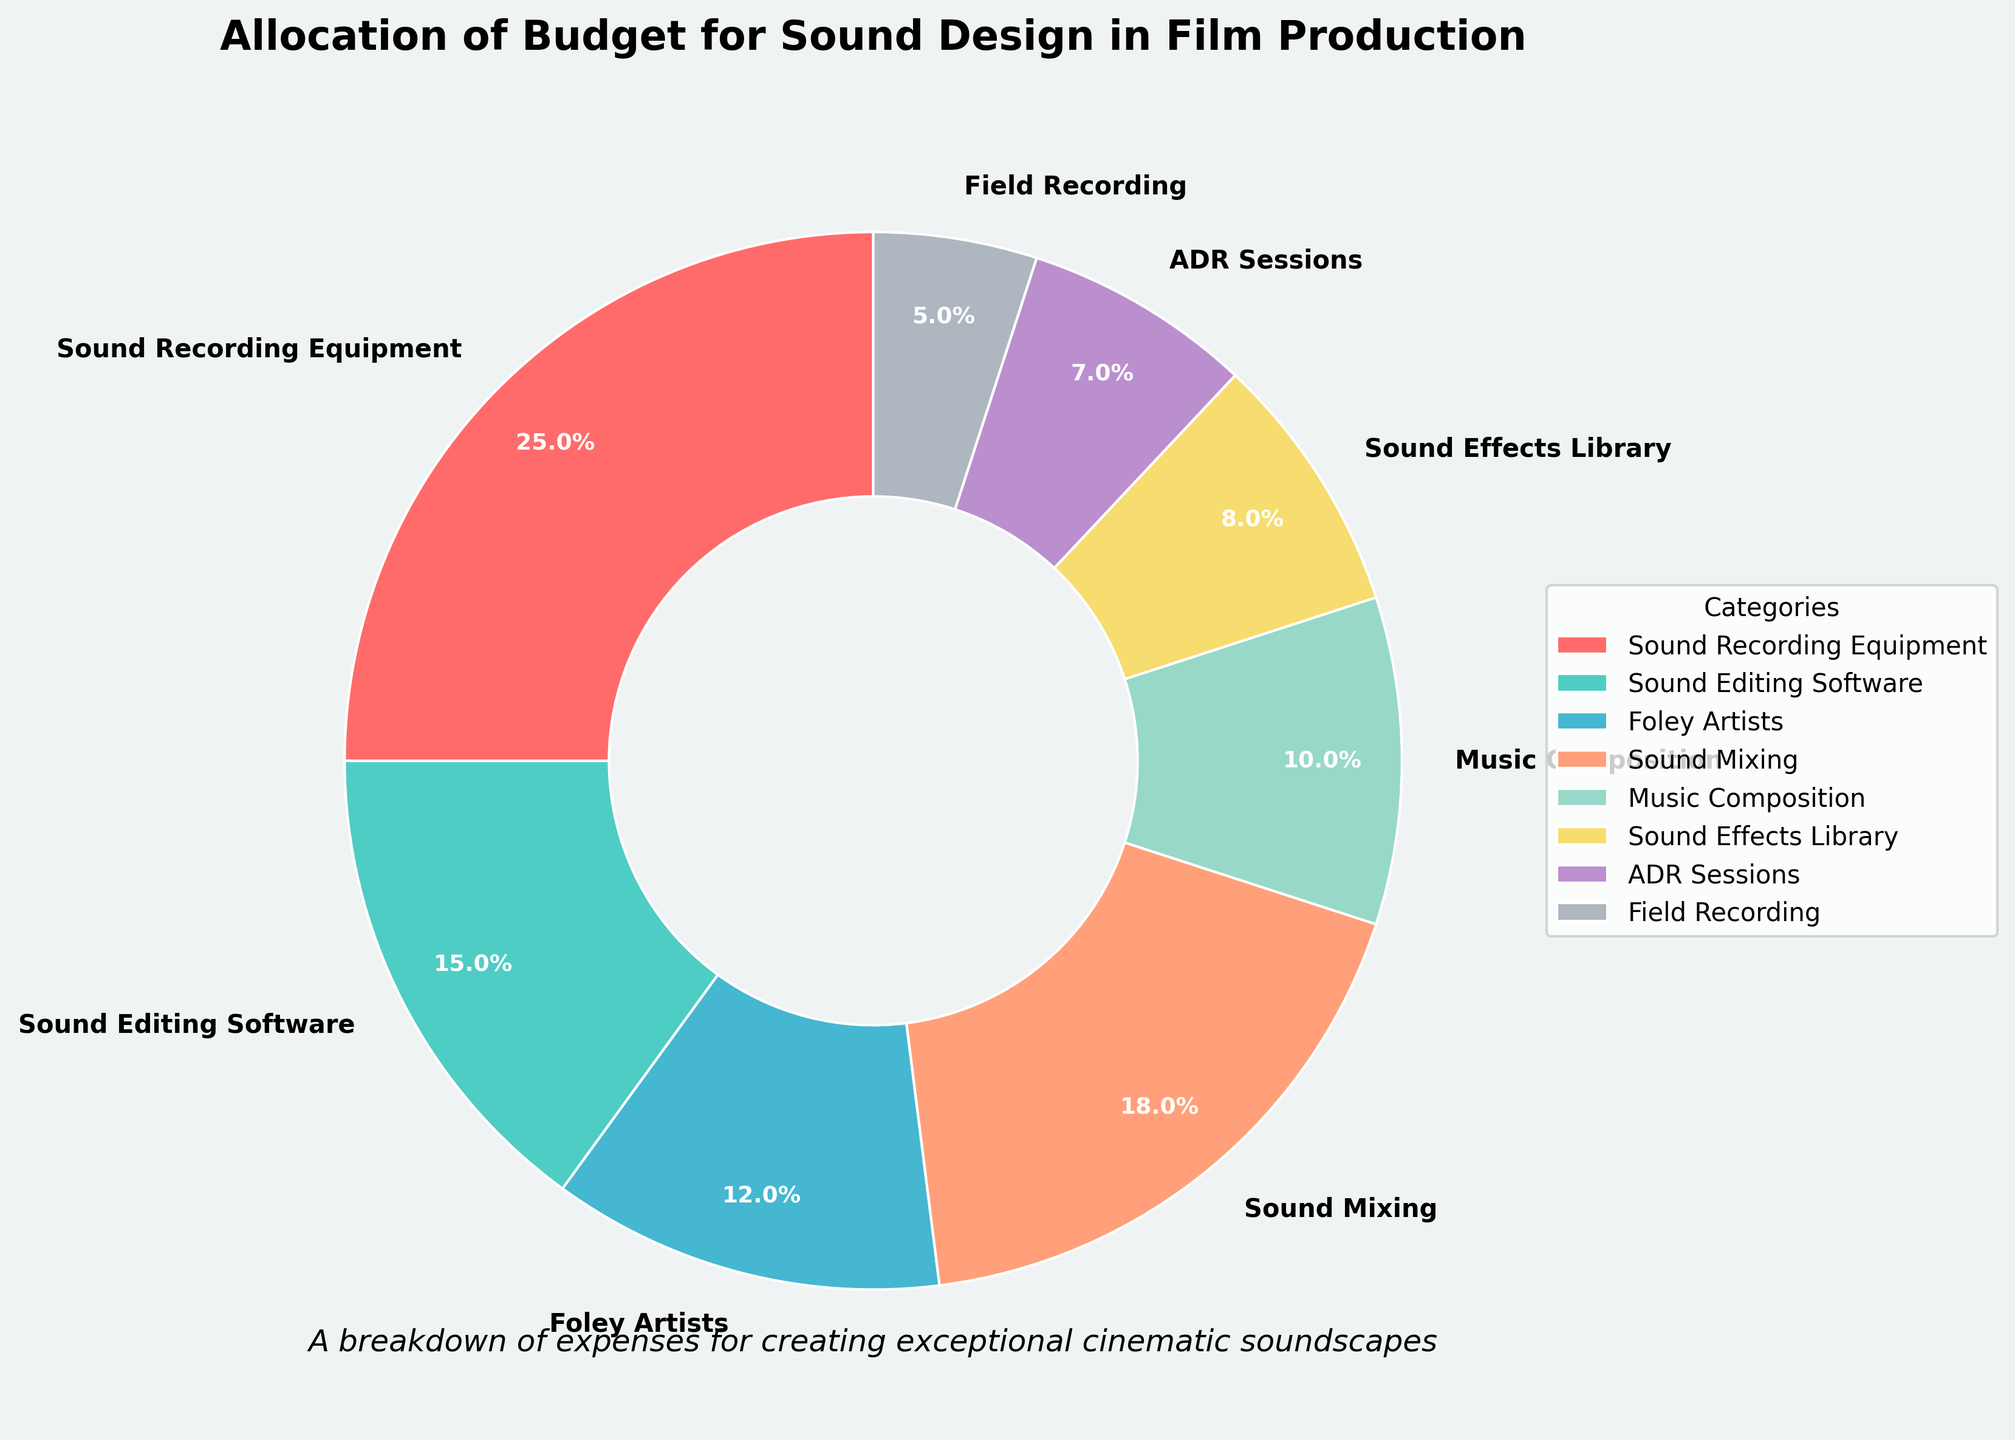Which category has the highest budget allocation? Examine the pie chart and identify the slice with the largest percentage. The largest slice corresponds to "Sound Recording Equipment" with 25%.
Answer: Sound Recording Equipment Which two categories combined make up approximately one-third of the budget? Combine the percentages of each category until the sum is around one-third (approx. 33.3%). "Sound Recording Equipment" (25%) and "Field Recording" (5%) collectively make up 30%, while "Sound Editing Software" (15%) and "Sound Mixing" (18%) sum up to 33%.
Answer: Sound Editing Software and Sound Mixing How much more budget is allocated to Foley Artists compared to ADR Sessions? Find the percentages for "Foley Artists" (12%) and "ADR Sessions" (7%), then subtract the smaller percentage from the larger one: 12% - 7% = 5%.
Answer: 5% Which category has the smallest budget allocation and what is its percentage? Identify the smallest slice in the pie chart, which corresponds to "Field Recording" with 5%.
Answer: Field Recording, 5% How does the budget for Music Composition compare to the budget for Sound Effects Library? Compare the percentages allocated to "Music Composition" (10%) and "Sound Effects Library" (8%). Since 10% is greater than 8%, "Music Composition" has a higher budget than "Sound Effects Library".
Answer: Music Composition has a higher budget What is the combined budget allocation for the three categories with the lowest percentages? Add the percentages of the categories "Field Recording" (5%), "ADR Sessions" (7%), and "Sound Effects Library" (8%). The combined allocation is 5% + 7% + 8% = 20%.
Answer: 20% What percentage of the budget is dedicated to sound mixing and music composition together? Add the percentages for "Sound Mixing" (18%) and "Music Composition" (10%). The combined percentage is 18% + 10% = 28%.
Answer: 28% Which categories have a budget allocation greater than 15%? Look at the pie chart and identify the categories with percentages greater than 15%. They are "Sound Recording Equipment" (25%) and "Sound Mixing" (18%).
Answer: Sound Recording Equipment and Sound Mixing Is the budget percentage for Sound Editing Software greater than that for Foley Artists? Compare the percentages for "Sound Editing Software" (15%) and "Foley Artists" (12%). Since 15% is greater than 12%, the budget for Sound Editing Software is greater.
Answer: Yes What percentage difference is there between the highest and lowest budget allocations? Find the highest and lowest percentages: "Sound Recording Equipment" (25%) and "Field Recording" (5%). Subtract the lowest percentage from the highest: 25% - 5% = 20%.
Answer: 20% 